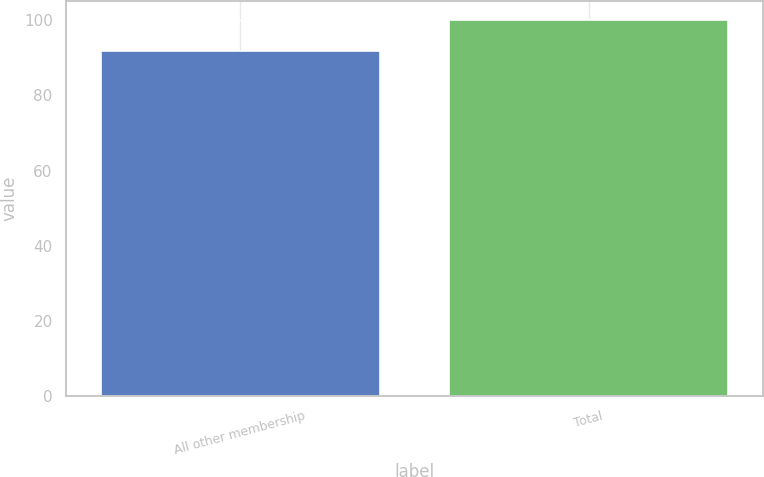<chart> <loc_0><loc_0><loc_500><loc_500><bar_chart><fcel>All other membership<fcel>Total<nl><fcel>91.9<fcel>100<nl></chart> 